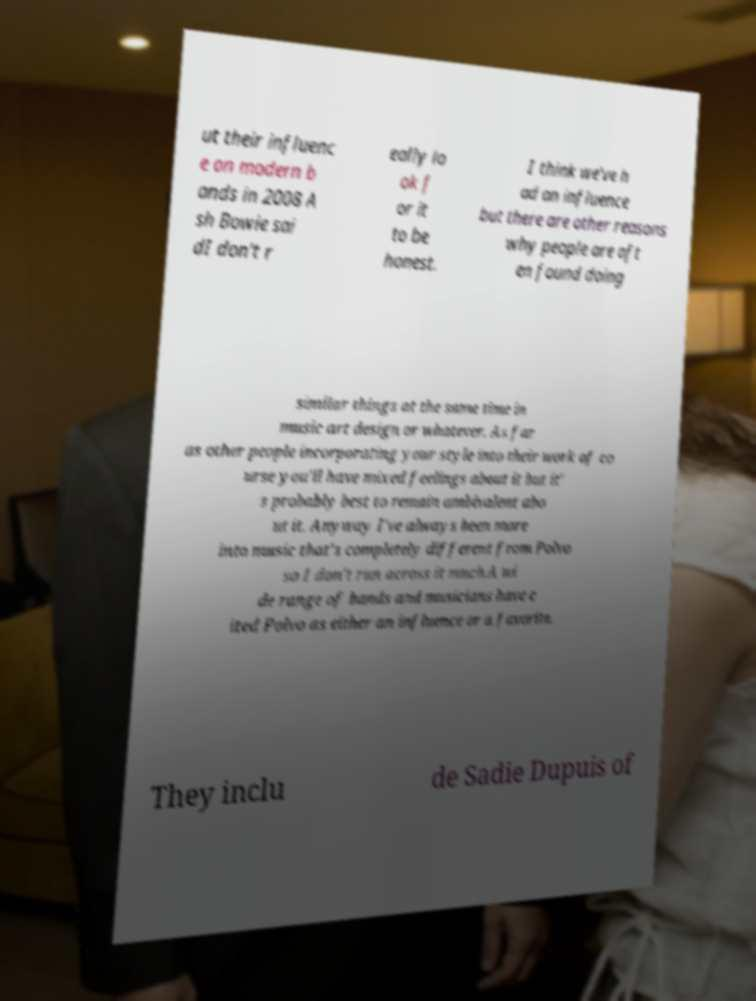I need the written content from this picture converted into text. Can you do that? ut their influenc e on modern b ands in 2008 A sh Bowie sai dI don't r eally lo ok f or it to be honest. I think we've h ad an influence but there are other reasons why people are oft en found doing similar things at the same time in music art design or whatever. As far as other people incorporating your style into their work of co urse you'll have mixed feelings about it but it' s probably best to remain ambivalent abo ut it. Anyway I've always been more into music that's completely different from Polvo so I don't run across it much.A wi de range of bands and musicians have c ited Polvo as either an influence or a favorite. They inclu de Sadie Dupuis of 